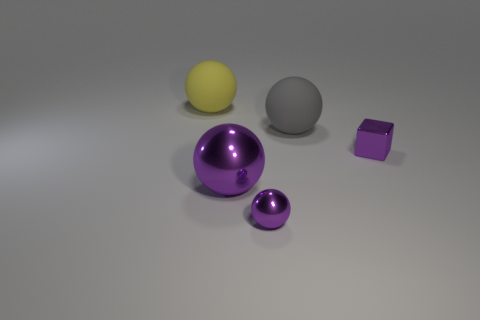Is there a big matte thing of the same color as the large metal sphere?
Make the answer very short. No. Are there any big purple objects?
Offer a very short reply. Yes. There is a tiny purple metallic object on the left side of the gray rubber thing; what is its shape?
Make the answer very short. Sphere. What number of things are to the left of the large gray sphere and in front of the large yellow matte thing?
Ensure brevity in your answer.  2. How many other things are the same size as the gray sphere?
Offer a terse response. 2. There is a matte object on the left side of the gray rubber sphere; is it the same shape as the small purple metallic object to the right of the big gray matte sphere?
Offer a terse response. No. What number of things are yellow balls or matte objects that are to the right of the yellow rubber thing?
Keep it short and to the point. 2. What material is the big ball that is behind the shiny block and in front of the big yellow matte sphere?
Your answer should be compact. Rubber. Is there any other thing that has the same shape as the large yellow object?
Your response must be concise. Yes. The big object that is made of the same material as the big gray ball is what color?
Offer a terse response. Yellow. 